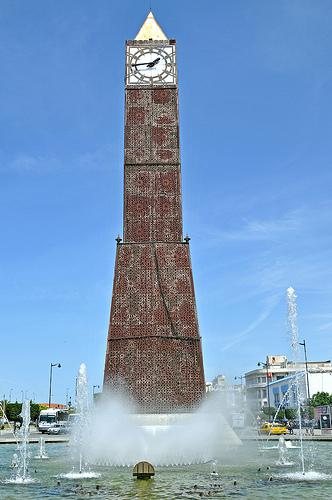Question: how is the weather?
Choices:
A. Cloudy.
B. Rainy.
C. Storming.
D. Sunny.
Answer with the letter. Answer: D Question: what material is the tower made of?
Choices:
A. Wood.
B. Clay.
C. Brick.
D. Metal.
Answer with the letter. Answer: C 